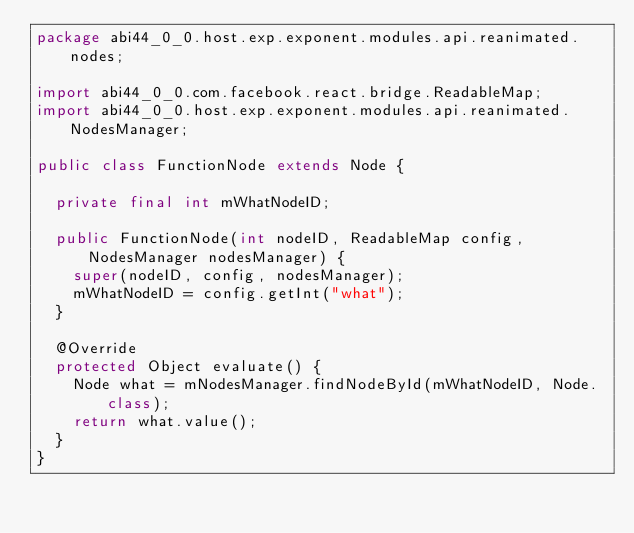Convert code to text. <code><loc_0><loc_0><loc_500><loc_500><_Java_>package abi44_0_0.host.exp.exponent.modules.api.reanimated.nodes;

import abi44_0_0.com.facebook.react.bridge.ReadableMap;
import abi44_0_0.host.exp.exponent.modules.api.reanimated.NodesManager;

public class FunctionNode extends Node {

  private final int mWhatNodeID;

  public FunctionNode(int nodeID, ReadableMap config, NodesManager nodesManager) {
    super(nodeID, config, nodesManager);
    mWhatNodeID = config.getInt("what");
  }

  @Override
  protected Object evaluate() {
    Node what = mNodesManager.findNodeById(mWhatNodeID, Node.class);
    return what.value();
  }
}
</code> 